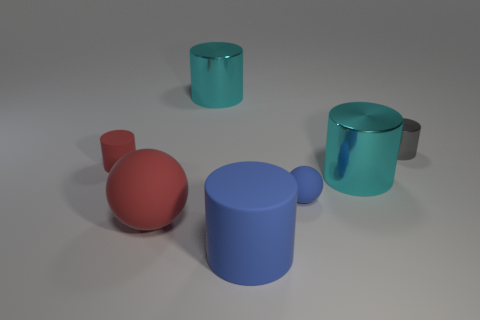Subtract all small matte cylinders. How many cylinders are left? 4 Subtract all gray cylinders. How many cylinders are left? 4 Subtract 1 cylinders. How many cylinders are left? 4 Subtract all purple cylinders. Subtract all red cubes. How many cylinders are left? 5 Add 1 large brown matte cylinders. How many objects exist? 8 Subtract all cylinders. How many objects are left? 2 Add 4 cylinders. How many cylinders are left? 9 Add 7 small matte cylinders. How many small matte cylinders exist? 8 Subtract 0 green balls. How many objects are left? 7 Subtract all cylinders. Subtract all red cylinders. How many objects are left? 1 